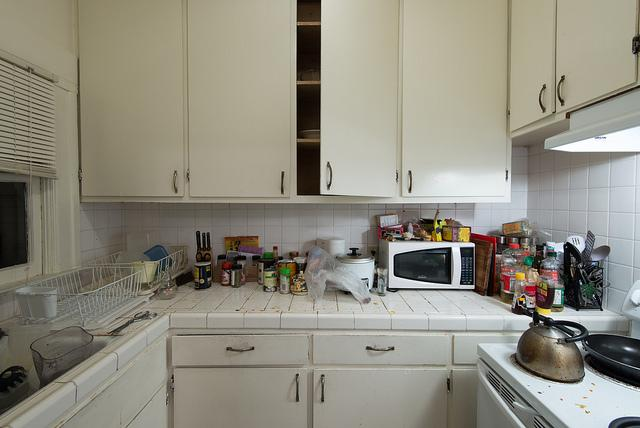What are the two rectangular baskets on the left counter for? drying dishes 